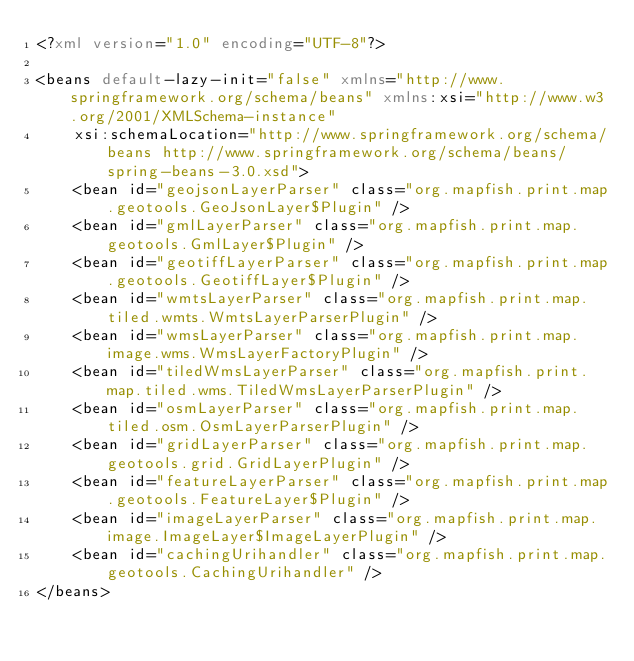<code> <loc_0><loc_0><loc_500><loc_500><_XML_><?xml version="1.0" encoding="UTF-8"?>

<beans default-lazy-init="false" xmlns="http://www.springframework.org/schema/beans" xmlns:xsi="http://www.w3.org/2001/XMLSchema-instance"
    xsi:schemaLocation="http://www.springframework.org/schema/beans http://www.springframework.org/schema/beans/spring-beans-3.0.xsd">
    <bean id="geojsonLayerParser" class="org.mapfish.print.map.geotools.GeoJsonLayer$Plugin" />
    <bean id="gmlLayerParser" class="org.mapfish.print.map.geotools.GmlLayer$Plugin" />
    <bean id="geotiffLayerParser" class="org.mapfish.print.map.geotools.GeotiffLayer$Plugin" />
    <bean id="wmtsLayerParser" class="org.mapfish.print.map.tiled.wmts.WmtsLayerParserPlugin" />
    <bean id="wmsLayerParser" class="org.mapfish.print.map.image.wms.WmsLayerFactoryPlugin" />
    <bean id="tiledWmsLayerParser" class="org.mapfish.print.map.tiled.wms.TiledWmsLayerParserPlugin" />
    <bean id="osmLayerParser" class="org.mapfish.print.map.tiled.osm.OsmLayerParserPlugin" />
    <bean id="gridLayerParser" class="org.mapfish.print.map.geotools.grid.GridLayerPlugin" />
    <bean id="featureLayerParser" class="org.mapfish.print.map.geotools.FeatureLayer$Plugin" />
    <bean id="imageLayerParser" class="org.mapfish.print.map.image.ImageLayer$ImageLayerPlugin" />
    <bean id="cachingUrihandler" class="org.mapfish.print.map.geotools.CachingUrihandler" />
</beans>
</code> 